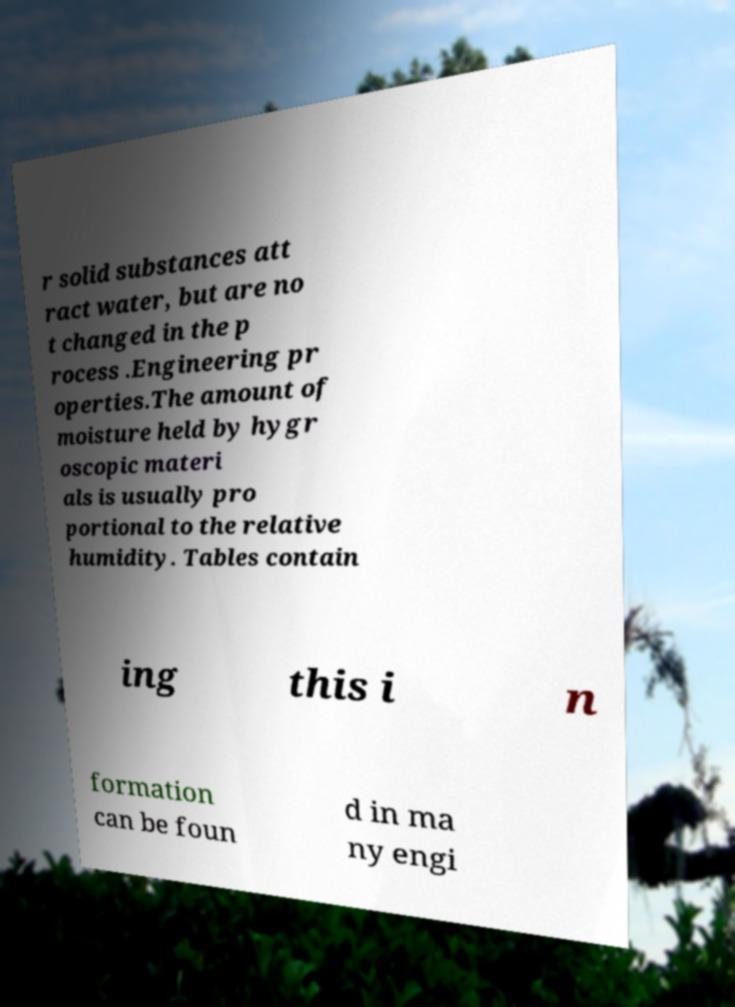There's text embedded in this image that I need extracted. Can you transcribe it verbatim? r solid substances att ract water, but are no t changed in the p rocess .Engineering pr operties.The amount of moisture held by hygr oscopic materi als is usually pro portional to the relative humidity. Tables contain ing this i n formation can be foun d in ma ny engi 